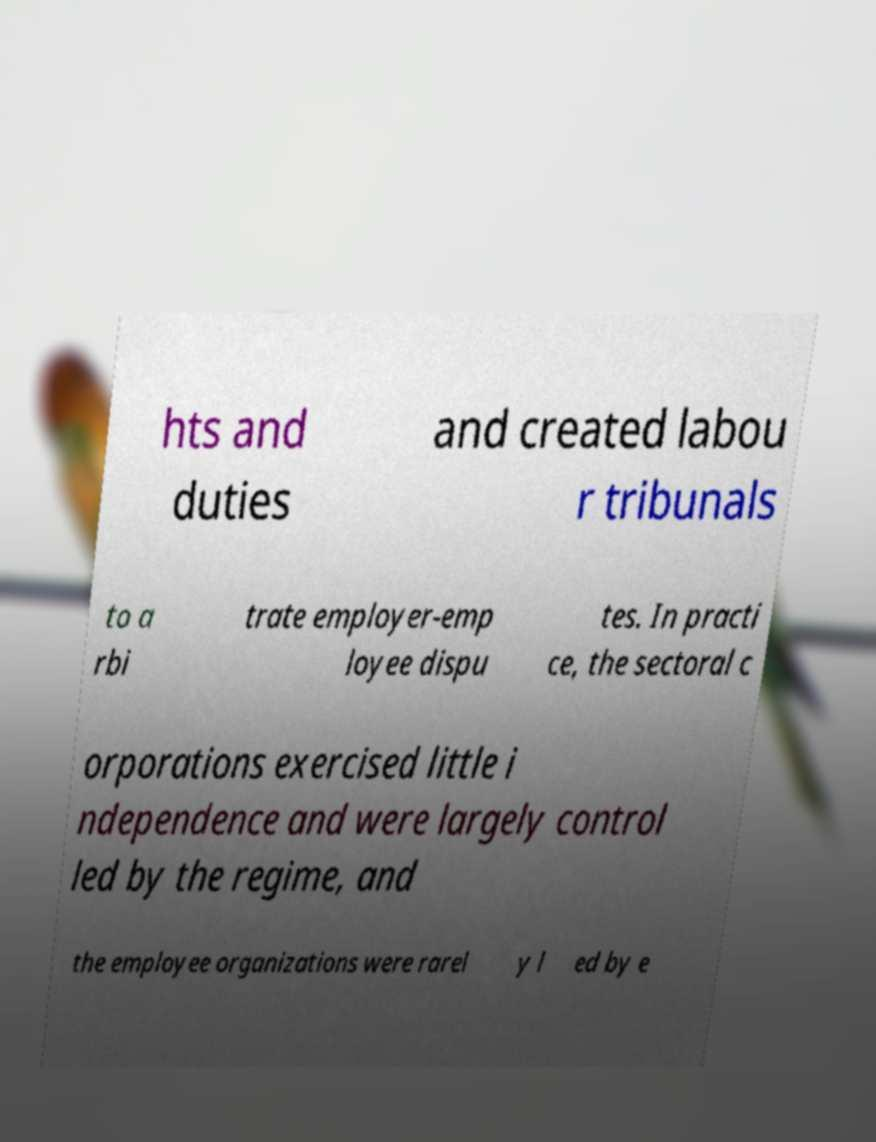I need the written content from this picture converted into text. Can you do that? hts and duties and created labou r tribunals to a rbi trate employer-emp loyee dispu tes. In practi ce, the sectoral c orporations exercised little i ndependence and were largely control led by the regime, and the employee organizations were rarel y l ed by e 